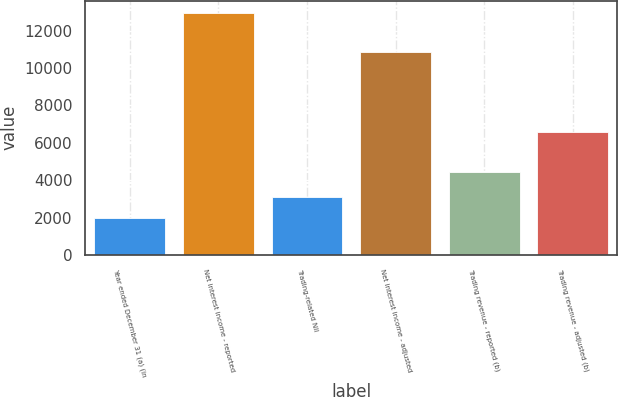<chart> <loc_0><loc_0><loc_500><loc_500><bar_chart><fcel>Year ended December 31 (a) (in<fcel>Net interest income - reported<fcel>Trading-related NII<fcel>Net interest income - adjusted<fcel>Trading revenue - reported (b)<fcel>Trading revenue - adjusted (b)<nl><fcel>2003<fcel>12965<fcel>3099.2<fcel>10836<fcel>4427<fcel>6556<nl></chart> 